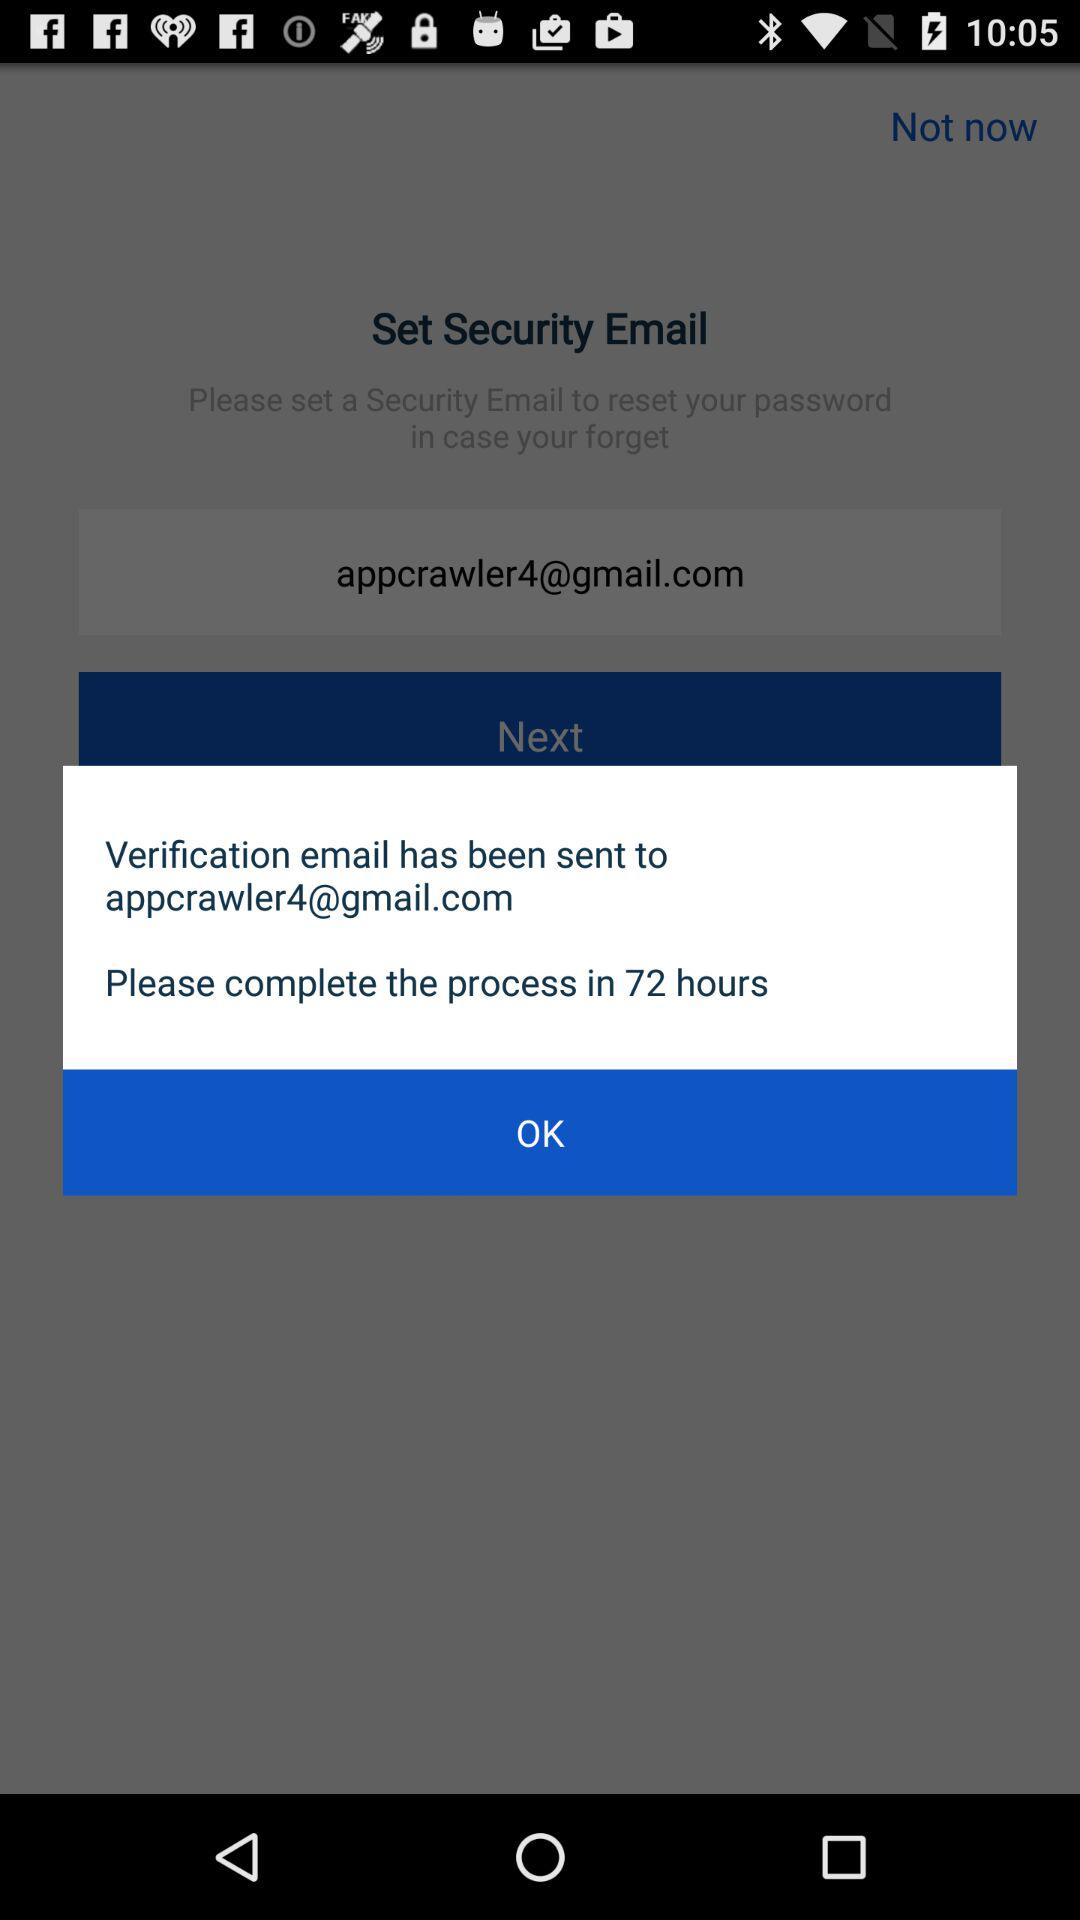How long do I have to complete the verification process?
Answer the question using a single word or phrase. 72 hours 